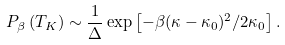Convert formula to latex. <formula><loc_0><loc_0><loc_500><loc_500>P _ { \beta } \left ( T _ { K } \right ) \sim \frac { 1 } { \Delta } \exp \left [ - \beta ( \kappa - \kappa _ { 0 } ) ^ { 2 } / 2 \kappa _ { 0 } \right ] .</formula> 